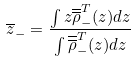<formula> <loc_0><loc_0><loc_500><loc_500>\overline { z } _ { - } = \frac { \int z \overline { \overline { \rho } } ^ { T } _ { - } ( z ) d z } { \int \overline { \overline { \rho } } ^ { T } _ { - } ( z ) d z } \\</formula> 